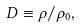Convert formula to latex. <formula><loc_0><loc_0><loc_500><loc_500>D \equiv \rho / \rho _ { 0 } ,</formula> 